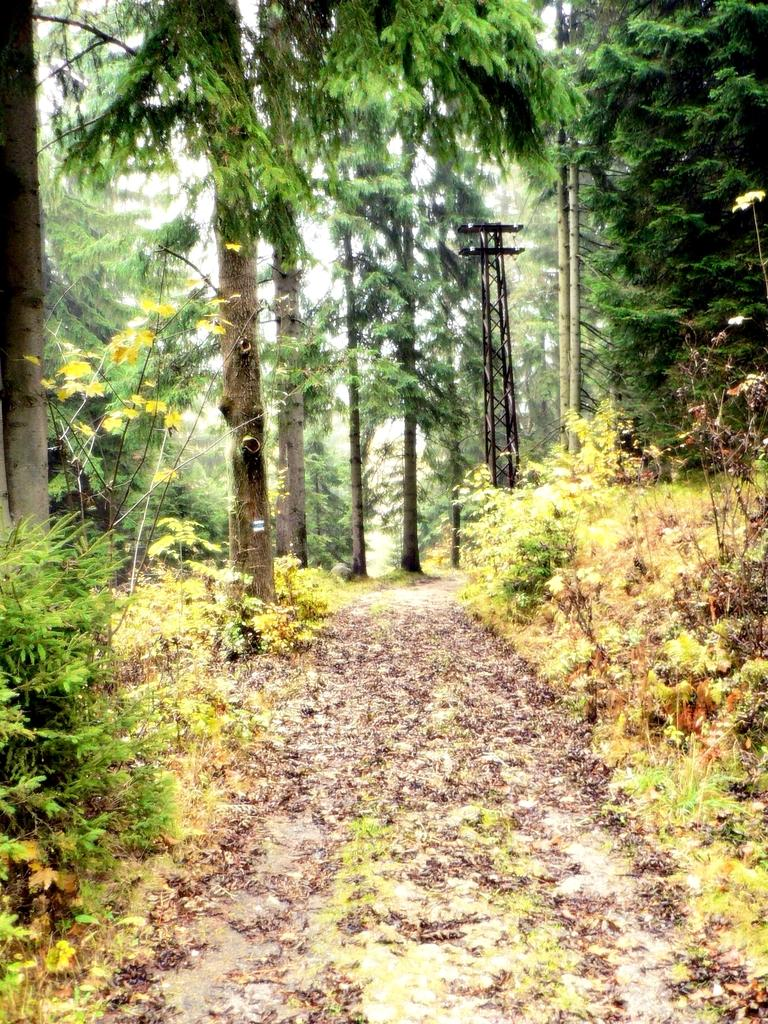What is the main subject in the center of the image? There is a way in the center of the image. What type of natural elements can be seen in the image? There are trees in the image. Are there any man-made structures visible in the image? Yes, there are poles in the image. What type of underwear is hanging on the poles in the image? There is no underwear present in the image; only trees and poles are visible. 